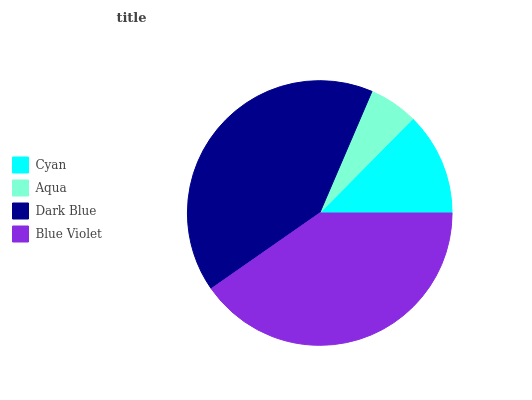Is Aqua the minimum?
Answer yes or no. Yes. Is Dark Blue the maximum?
Answer yes or no. Yes. Is Dark Blue the minimum?
Answer yes or no. No. Is Aqua the maximum?
Answer yes or no. No. Is Dark Blue greater than Aqua?
Answer yes or no. Yes. Is Aqua less than Dark Blue?
Answer yes or no. Yes. Is Aqua greater than Dark Blue?
Answer yes or no. No. Is Dark Blue less than Aqua?
Answer yes or no. No. Is Blue Violet the high median?
Answer yes or no. Yes. Is Cyan the low median?
Answer yes or no. Yes. Is Dark Blue the high median?
Answer yes or no. No. Is Aqua the low median?
Answer yes or no. No. 